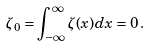<formula> <loc_0><loc_0><loc_500><loc_500>\zeta _ { 0 } = \int _ { - \infty } ^ { \infty } \zeta ( x ) d x = 0 \, .</formula> 